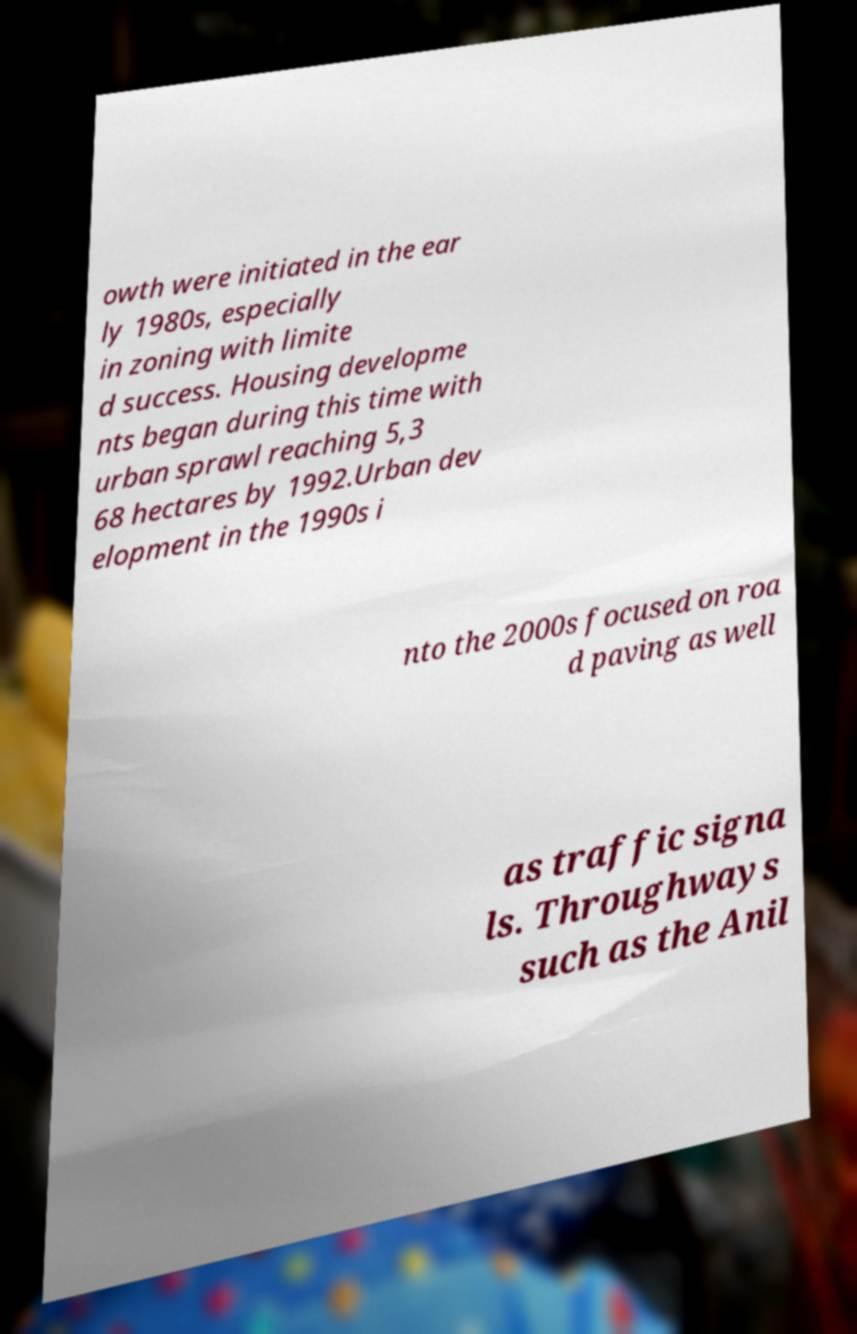What messages or text are displayed in this image? I need them in a readable, typed format. owth were initiated in the ear ly 1980s, especially in zoning with limite d success. Housing developme nts began during this time with urban sprawl reaching 5,3 68 hectares by 1992.Urban dev elopment in the 1990s i nto the 2000s focused on roa d paving as well as traffic signa ls. Throughways such as the Anil 